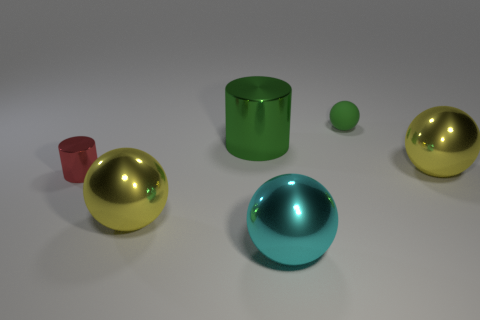Subtract all matte spheres. How many spheres are left? 3 Subtract all yellow spheres. How many spheres are left? 2 Subtract 4 balls. How many balls are left? 0 Add 4 small green rubber spheres. How many objects exist? 10 Subtract all cylinders. How many objects are left? 4 Add 6 tiny blue blocks. How many tiny blue blocks exist? 6 Subtract 0 cyan cubes. How many objects are left? 6 Subtract all red cylinders. Subtract all cyan balls. How many cylinders are left? 1 Subtract all gray spheres. How many cyan cylinders are left? 0 Subtract all green things. Subtract all tiny green matte spheres. How many objects are left? 3 